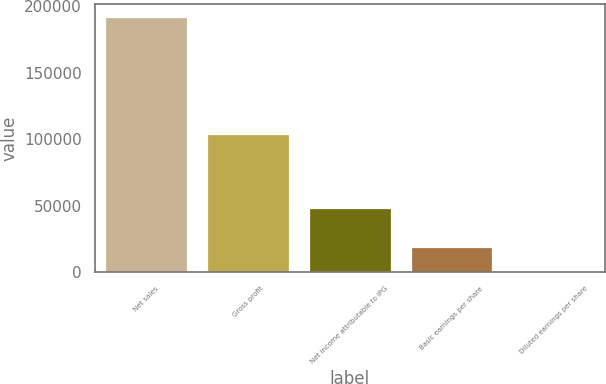Convert chart. <chart><loc_0><loc_0><loc_500><loc_500><bar_chart><fcel>Net sales<fcel>Gross profit<fcel>Net income attributable to IPG<fcel>Basic earnings per share<fcel>Diluted earnings per share<nl><fcel>192204<fcel>104227<fcel>48283<fcel>19221.2<fcel>0.92<nl></chart> 